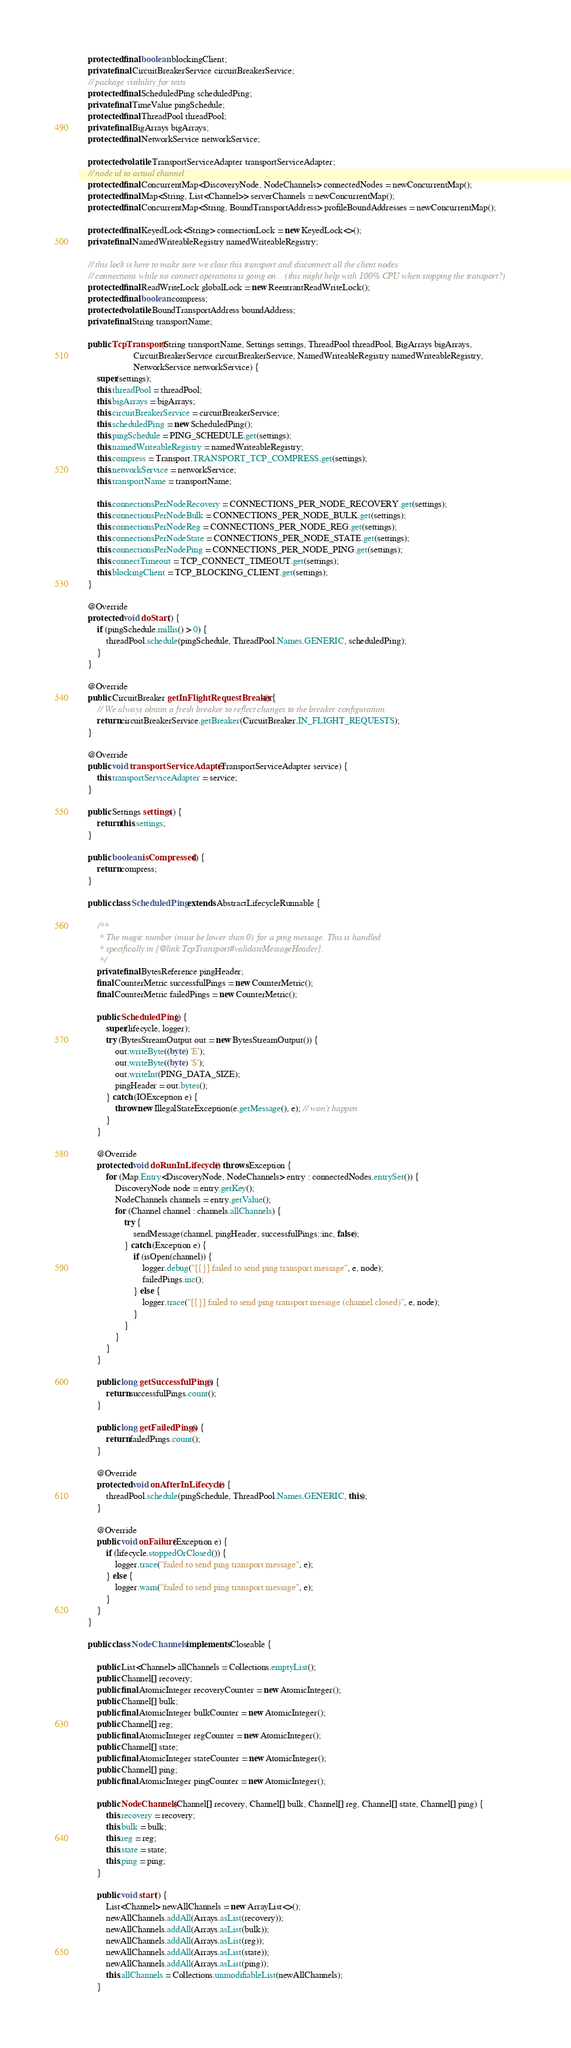Convert code to text. <code><loc_0><loc_0><loc_500><loc_500><_Java_>    protected final boolean blockingClient;
    private final CircuitBreakerService circuitBreakerService;
    // package visibility for tests
    protected final ScheduledPing scheduledPing;
    private final TimeValue pingSchedule;
    protected final ThreadPool threadPool;
    private final BigArrays bigArrays;
    protected final NetworkService networkService;

    protected volatile TransportServiceAdapter transportServiceAdapter;
    // node id to actual channel
    protected final ConcurrentMap<DiscoveryNode, NodeChannels> connectedNodes = newConcurrentMap();
    protected final Map<String, List<Channel>> serverChannels = newConcurrentMap();
    protected final ConcurrentMap<String, BoundTransportAddress> profileBoundAddresses = newConcurrentMap();

    protected final KeyedLock<String> connectionLock = new KeyedLock<>();
    private final NamedWriteableRegistry namedWriteableRegistry;

    // this lock is here to make sure we close this transport and disconnect all the client nodes
    // connections while no connect operations is going on... (this might help with 100% CPU when stopping the transport?)
    protected final ReadWriteLock globalLock = new ReentrantReadWriteLock();
    protected final boolean compress;
    protected volatile BoundTransportAddress boundAddress;
    private final String transportName;

    public TcpTransport(String transportName, Settings settings, ThreadPool threadPool, BigArrays bigArrays,
                        CircuitBreakerService circuitBreakerService, NamedWriteableRegistry namedWriteableRegistry,
                        NetworkService networkService) {
        super(settings);
        this.threadPool = threadPool;
        this.bigArrays = bigArrays;
        this.circuitBreakerService = circuitBreakerService;
        this.scheduledPing = new ScheduledPing();
        this.pingSchedule = PING_SCHEDULE.get(settings);
        this.namedWriteableRegistry = namedWriteableRegistry;
        this.compress = Transport.TRANSPORT_TCP_COMPRESS.get(settings);
        this.networkService = networkService;
        this.transportName = transportName;

        this.connectionsPerNodeRecovery = CONNECTIONS_PER_NODE_RECOVERY.get(settings);
        this.connectionsPerNodeBulk = CONNECTIONS_PER_NODE_BULK.get(settings);
        this.connectionsPerNodeReg = CONNECTIONS_PER_NODE_REG.get(settings);
        this.connectionsPerNodeState = CONNECTIONS_PER_NODE_STATE.get(settings);
        this.connectionsPerNodePing = CONNECTIONS_PER_NODE_PING.get(settings);
        this.connectTimeout = TCP_CONNECT_TIMEOUT.get(settings);
        this.blockingClient = TCP_BLOCKING_CLIENT.get(settings);
    }

    @Override
    protected void doStart() {
        if (pingSchedule.millis() > 0) {
            threadPool.schedule(pingSchedule, ThreadPool.Names.GENERIC, scheduledPing);
        }
    }

    @Override
    public CircuitBreaker getInFlightRequestBreaker() {
        // We always obtain a fresh breaker to reflect changes to the breaker configuration.
        return circuitBreakerService.getBreaker(CircuitBreaker.IN_FLIGHT_REQUESTS);
    }

    @Override
    public void transportServiceAdapter(TransportServiceAdapter service) {
        this.transportServiceAdapter = service;
    }

    public Settings settings() {
        return this.settings;
    }

    public boolean isCompressed() {
        return compress;
    }

    public class ScheduledPing extends AbstractLifecycleRunnable {

        /**
         * The magic number (must be lower than 0) for a ping message. This is handled
         * specifically in {@link TcpTransport#validateMessageHeader}.
         */
        private final BytesReference pingHeader;
        final CounterMetric successfulPings = new CounterMetric();
        final CounterMetric failedPings = new CounterMetric();

        public ScheduledPing() {
            super(lifecycle, logger);
            try (BytesStreamOutput out = new BytesStreamOutput()) {
                out.writeByte((byte) 'E');
                out.writeByte((byte) 'S');
                out.writeInt(PING_DATA_SIZE);
                pingHeader = out.bytes();
            } catch (IOException e) {
                throw new IllegalStateException(e.getMessage(), e); // won't happen
            }
        }

        @Override
        protected void doRunInLifecycle() throws Exception {
            for (Map.Entry<DiscoveryNode, NodeChannels> entry : connectedNodes.entrySet()) {
                DiscoveryNode node = entry.getKey();
                NodeChannels channels = entry.getValue();
                for (Channel channel : channels.allChannels) {
                    try {
                        sendMessage(channel, pingHeader, successfulPings::inc, false);
                    } catch (Exception e) {
                        if (isOpen(channel)) {
                            logger.debug("[{}] failed to send ping transport message", e, node);
                            failedPings.inc();
                        } else {
                            logger.trace("[{}] failed to send ping transport message (channel closed)", e, node);
                        }
                    }
                }
            }
        }

        public long getSuccessfulPings() {
            return successfulPings.count();
        }

        public long getFailedPings() {
            return failedPings.count();
        }

        @Override
        protected void onAfterInLifecycle() {
            threadPool.schedule(pingSchedule, ThreadPool.Names.GENERIC, this);
        }

        @Override
        public void onFailure(Exception e) {
            if (lifecycle.stoppedOrClosed()) {
                logger.trace("failed to send ping transport message", e);
            } else {
                logger.warn("failed to send ping transport message", e);
            }
        }
    }

    public class NodeChannels implements Closeable {

        public List<Channel> allChannels = Collections.emptyList();
        public Channel[] recovery;
        public final AtomicInteger recoveryCounter = new AtomicInteger();
        public Channel[] bulk;
        public final AtomicInteger bulkCounter = new AtomicInteger();
        public Channel[] reg;
        public final AtomicInteger regCounter = new AtomicInteger();
        public Channel[] state;
        public final AtomicInteger stateCounter = new AtomicInteger();
        public Channel[] ping;
        public final AtomicInteger pingCounter = new AtomicInteger();

        public NodeChannels(Channel[] recovery, Channel[] bulk, Channel[] reg, Channel[] state, Channel[] ping) {
            this.recovery = recovery;
            this.bulk = bulk;
            this.reg = reg;
            this.state = state;
            this.ping = ping;
        }

        public void start() {
            List<Channel> newAllChannels = new ArrayList<>();
            newAllChannels.addAll(Arrays.asList(recovery));
            newAllChannels.addAll(Arrays.asList(bulk));
            newAllChannels.addAll(Arrays.asList(reg));
            newAllChannels.addAll(Arrays.asList(state));
            newAllChannels.addAll(Arrays.asList(ping));
            this.allChannels = Collections.unmodifiableList(newAllChannels);
        }
</code> 